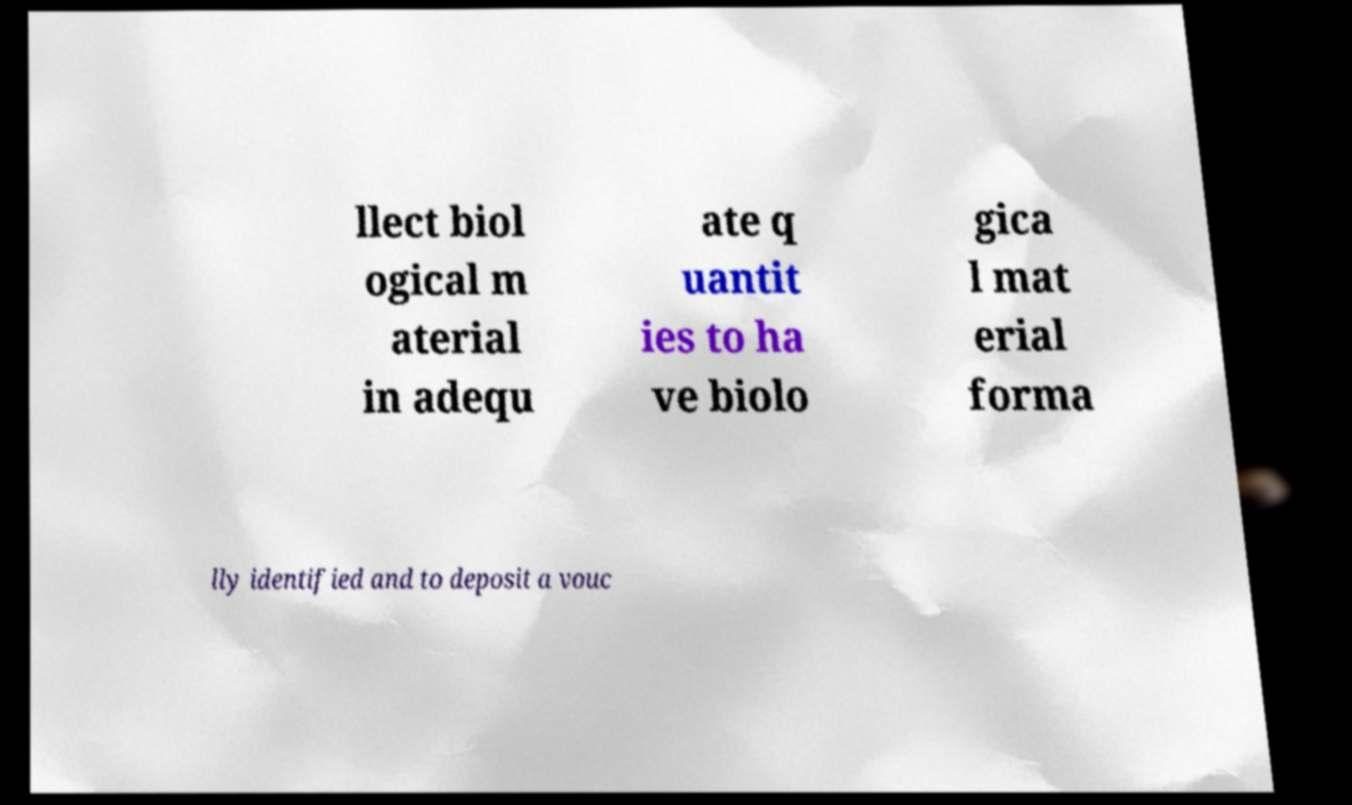Can you accurately transcribe the text from the provided image for me? llect biol ogical m aterial in adequ ate q uantit ies to ha ve biolo gica l mat erial forma lly identified and to deposit a vouc 